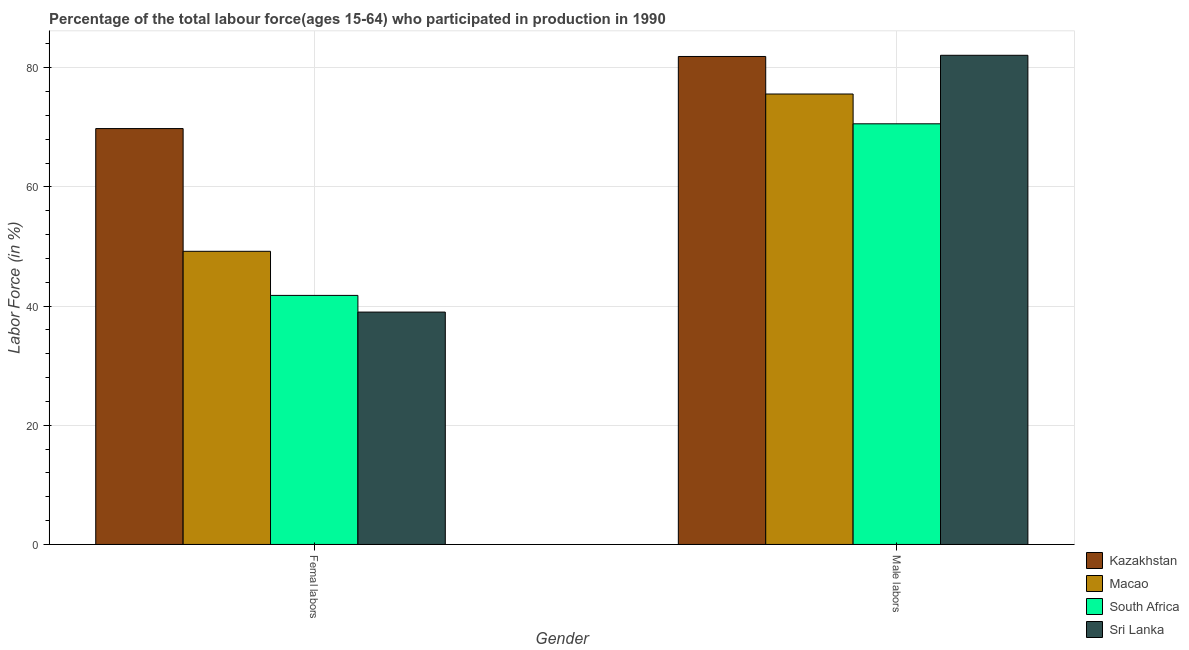How many different coloured bars are there?
Make the answer very short. 4. Are the number of bars per tick equal to the number of legend labels?
Make the answer very short. Yes. What is the label of the 1st group of bars from the left?
Provide a succinct answer. Femal labors. What is the percentage of male labour force in Kazakhstan?
Offer a very short reply. 81.9. Across all countries, what is the maximum percentage of female labor force?
Your response must be concise. 69.8. In which country was the percentage of female labor force maximum?
Give a very brief answer. Kazakhstan. In which country was the percentage of female labor force minimum?
Your answer should be very brief. Sri Lanka. What is the total percentage of female labor force in the graph?
Provide a short and direct response. 199.8. What is the difference between the percentage of male labour force in Kazakhstan and that in Macao?
Offer a terse response. 6.3. What is the difference between the percentage of male labour force in Sri Lanka and the percentage of female labor force in Kazakhstan?
Offer a very short reply. 12.3. What is the average percentage of female labor force per country?
Ensure brevity in your answer.  49.95. What is the difference between the percentage of female labor force and percentage of male labour force in Macao?
Your response must be concise. -26.4. What is the ratio of the percentage of female labor force in South Africa to that in Sri Lanka?
Your answer should be very brief. 1.07. In how many countries, is the percentage of female labor force greater than the average percentage of female labor force taken over all countries?
Your answer should be compact. 1. What does the 1st bar from the left in Male labors represents?
Your response must be concise. Kazakhstan. What does the 1st bar from the right in Male labors represents?
Offer a very short reply. Sri Lanka. How many bars are there?
Provide a short and direct response. 8. How many countries are there in the graph?
Make the answer very short. 4. Does the graph contain any zero values?
Your answer should be very brief. No. Does the graph contain grids?
Provide a short and direct response. Yes. How are the legend labels stacked?
Ensure brevity in your answer.  Vertical. What is the title of the graph?
Offer a terse response. Percentage of the total labour force(ages 15-64) who participated in production in 1990. What is the label or title of the Y-axis?
Provide a short and direct response. Labor Force (in %). What is the Labor Force (in %) in Kazakhstan in Femal labors?
Provide a succinct answer. 69.8. What is the Labor Force (in %) of Macao in Femal labors?
Offer a very short reply. 49.2. What is the Labor Force (in %) of South Africa in Femal labors?
Your answer should be compact. 41.8. What is the Labor Force (in %) of Kazakhstan in Male labors?
Give a very brief answer. 81.9. What is the Labor Force (in %) of Macao in Male labors?
Provide a succinct answer. 75.6. What is the Labor Force (in %) of South Africa in Male labors?
Offer a terse response. 70.6. What is the Labor Force (in %) in Sri Lanka in Male labors?
Provide a short and direct response. 82.1. Across all Gender, what is the maximum Labor Force (in %) in Kazakhstan?
Provide a succinct answer. 81.9. Across all Gender, what is the maximum Labor Force (in %) of Macao?
Ensure brevity in your answer.  75.6. Across all Gender, what is the maximum Labor Force (in %) in South Africa?
Keep it short and to the point. 70.6. Across all Gender, what is the maximum Labor Force (in %) of Sri Lanka?
Give a very brief answer. 82.1. Across all Gender, what is the minimum Labor Force (in %) of Kazakhstan?
Offer a very short reply. 69.8. Across all Gender, what is the minimum Labor Force (in %) in Macao?
Make the answer very short. 49.2. Across all Gender, what is the minimum Labor Force (in %) in South Africa?
Give a very brief answer. 41.8. Across all Gender, what is the minimum Labor Force (in %) in Sri Lanka?
Ensure brevity in your answer.  39. What is the total Labor Force (in %) in Kazakhstan in the graph?
Your answer should be very brief. 151.7. What is the total Labor Force (in %) in Macao in the graph?
Make the answer very short. 124.8. What is the total Labor Force (in %) of South Africa in the graph?
Provide a succinct answer. 112.4. What is the total Labor Force (in %) in Sri Lanka in the graph?
Provide a short and direct response. 121.1. What is the difference between the Labor Force (in %) of Macao in Femal labors and that in Male labors?
Give a very brief answer. -26.4. What is the difference between the Labor Force (in %) in South Africa in Femal labors and that in Male labors?
Provide a succinct answer. -28.8. What is the difference between the Labor Force (in %) of Sri Lanka in Femal labors and that in Male labors?
Give a very brief answer. -43.1. What is the difference between the Labor Force (in %) in Kazakhstan in Femal labors and the Labor Force (in %) in Macao in Male labors?
Ensure brevity in your answer.  -5.8. What is the difference between the Labor Force (in %) of Kazakhstan in Femal labors and the Labor Force (in %) of South Africa in Male labors?
Your answer should be very brief. -0.8. What is the difference between the Labor Force (in %) of Kazakhstan in Femal labors and the Labor Force (in %) of Sri Lanka in Male labors?
Provide a succinct answer. -12.3. What is the difference between the Labor Force (in %) in Macao in Femal labors and the Labor Force (in %) in South Africa in Male labors?
Your response must be concise. -21.4. What is the difference between the Labor Force (in %) of Macao in Femal labors and the Labor Force (in %) of Sri Lanka in Male labors?
Ensure brevity in your answer.  -32.9. What is the difference between the Labor Force (in %) in South Africa in Femal labors and the Labor Force (in %) in Sri Lanka in Male labors?
Ensure brevity in your answer.  -40.3. What is the average Labor Force (in %) in Kazakhstan per Gender?
Your response must be concise. 75.85. What is the average Labor Force (in %) of Macao per Gender?
Keep it short and to the point. 62.4. What is the average Labor Force (in %) of South Africa per Gender?
Provide a short and direct response. 56.2. What is the average Labor Force (in %) in Sri Lanka per Gender?
Provide a succinct answer. 60.55. What is the difference between the Labor Force (in %) of Kazakhstan and Labor Force (in %) of Macao in Femal labors?
Keep it short and to the point. 20.6. What is the difference between the Labor Force (in %) in Kazakhstan and Labor Force (in %) in Sri Lanka in Femal labors?
Offer a terse response. 30.8. What is the difference between the Labor Force (in %) of Macao and Labor Force (in %) of South Africa in Femal labors?
Make the answer very short. 7.4. What is the difference between the Labor Force (in %) of Macao and Labor Force (in %) of Sri Lanka in Femal labors?
Provide a short and direct response. 10.2. What is the difference between the Labor Force (in %) of Kazakhstan and Labor Force (in %) of South Africa in Male labors?
Your answer should be compact. 11.3. What is the difference between the Labor Force (in %) in Macao and Labor Force (in %) in Sri Lanka in Male labors?
Give a very brief answer. -6.5. What is the ratio of the Labor Force (in %) of Kazakhstan in Femal labors to that in Male labors?
Provide a succinct answer. 0.85. What is the ratio of the Labor Force (in %) in Macao in Femal labors to that in Male labors?
Your answer should be very brief. 0.65. What is the ratio of the Labor Force (in %) in South Africa in Femal labors to that in Male labors?
Ensure brevity in your answer.  0.59. What is the ratio of the Labor Force (in %) of Sri Lanka in Femal labors to that in Male labors?
Give a very brief answer. 0.47. What is the difference between the highest and the second highest Labor Force (in %) of Macao?
Provide a succinct answer. 26.4. What is the difference between the highest and the second highest Labor Force (in %) of South Africa?
Offer a terse response. 28.8. What is the difference between the highest and the second highest Labor Force (in %) in Sri Lanka?
Provide a succinct answer. 43.1. What is the difference between the highest and the lowest Labor Force (in %) of Kazakhstan?
Your response must be concise. 12.1. What is the difference between the highest and the lowest Labor Force (in %) of Macao?
Your response must be concise. 26.4. What is the difference between the highest and the lowest Labor Force (in %) in South Africa?
Make the answer very short. 28.8. What is the difference between the highest and the lowest Labor Force (in %) of Sri Lanka?
Provide a succinct answer. 43.1. 